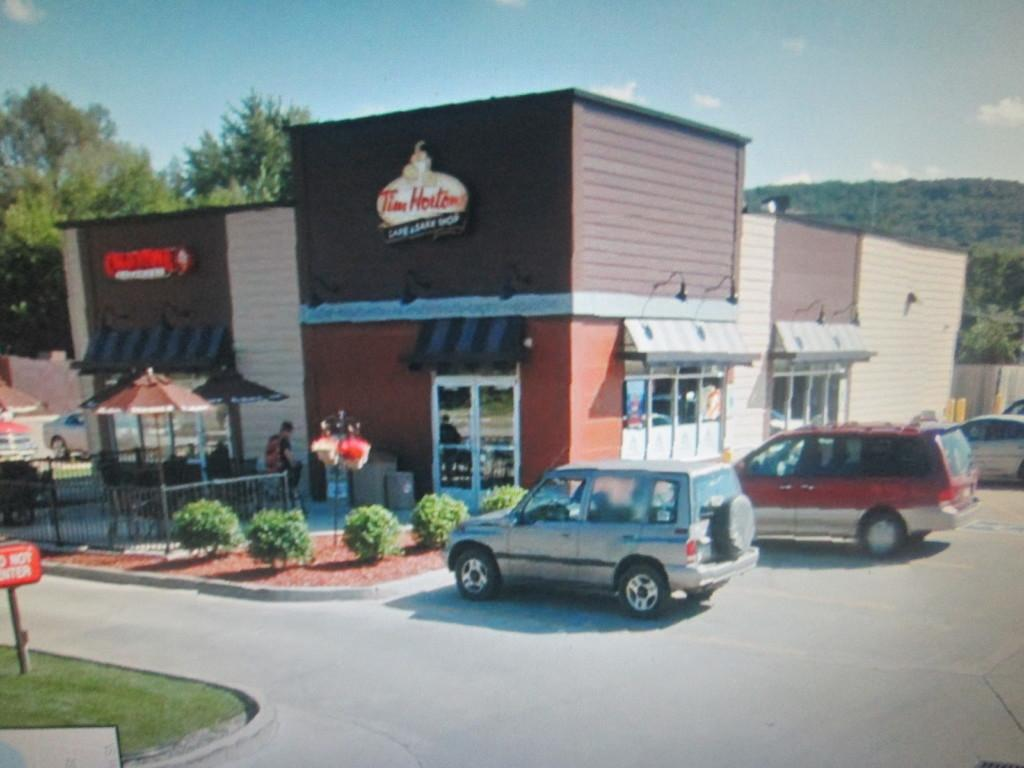What type of vehicles can be seen on the road in the image? There are cars on the road in the image. What is located in front of the cars? There are plants in front of the cars. What can be seen in the background of the image? There are buildings, trees, and the sky visible in the background of the image. How many lizards are crawling on the cars in the image? There are no lizards present in the image; it only features cars, plants, buildings, trees, and the sky. 